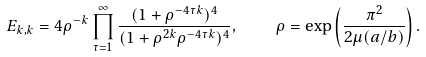Convert formula to latex. <formula><loc_0><loc_0><loc_500><loc_500>E _ { k , k } = 4 \rho ^ { - k } \prod _ { \tau = 1 } ^ { \infty } \frac { ( 1 + \rho ^ { - 4 \tau k } ) ^ { 4 } } { ( 1 + \rho ^ { 2 k } \rho ^ { - 4 \tau k } ) ^ { 4 } } , \quad \rho = \exp \left ( \frac { \pi ^ { 2 } } { 2 \mu ( a / b ) } \right ) .</formula> 